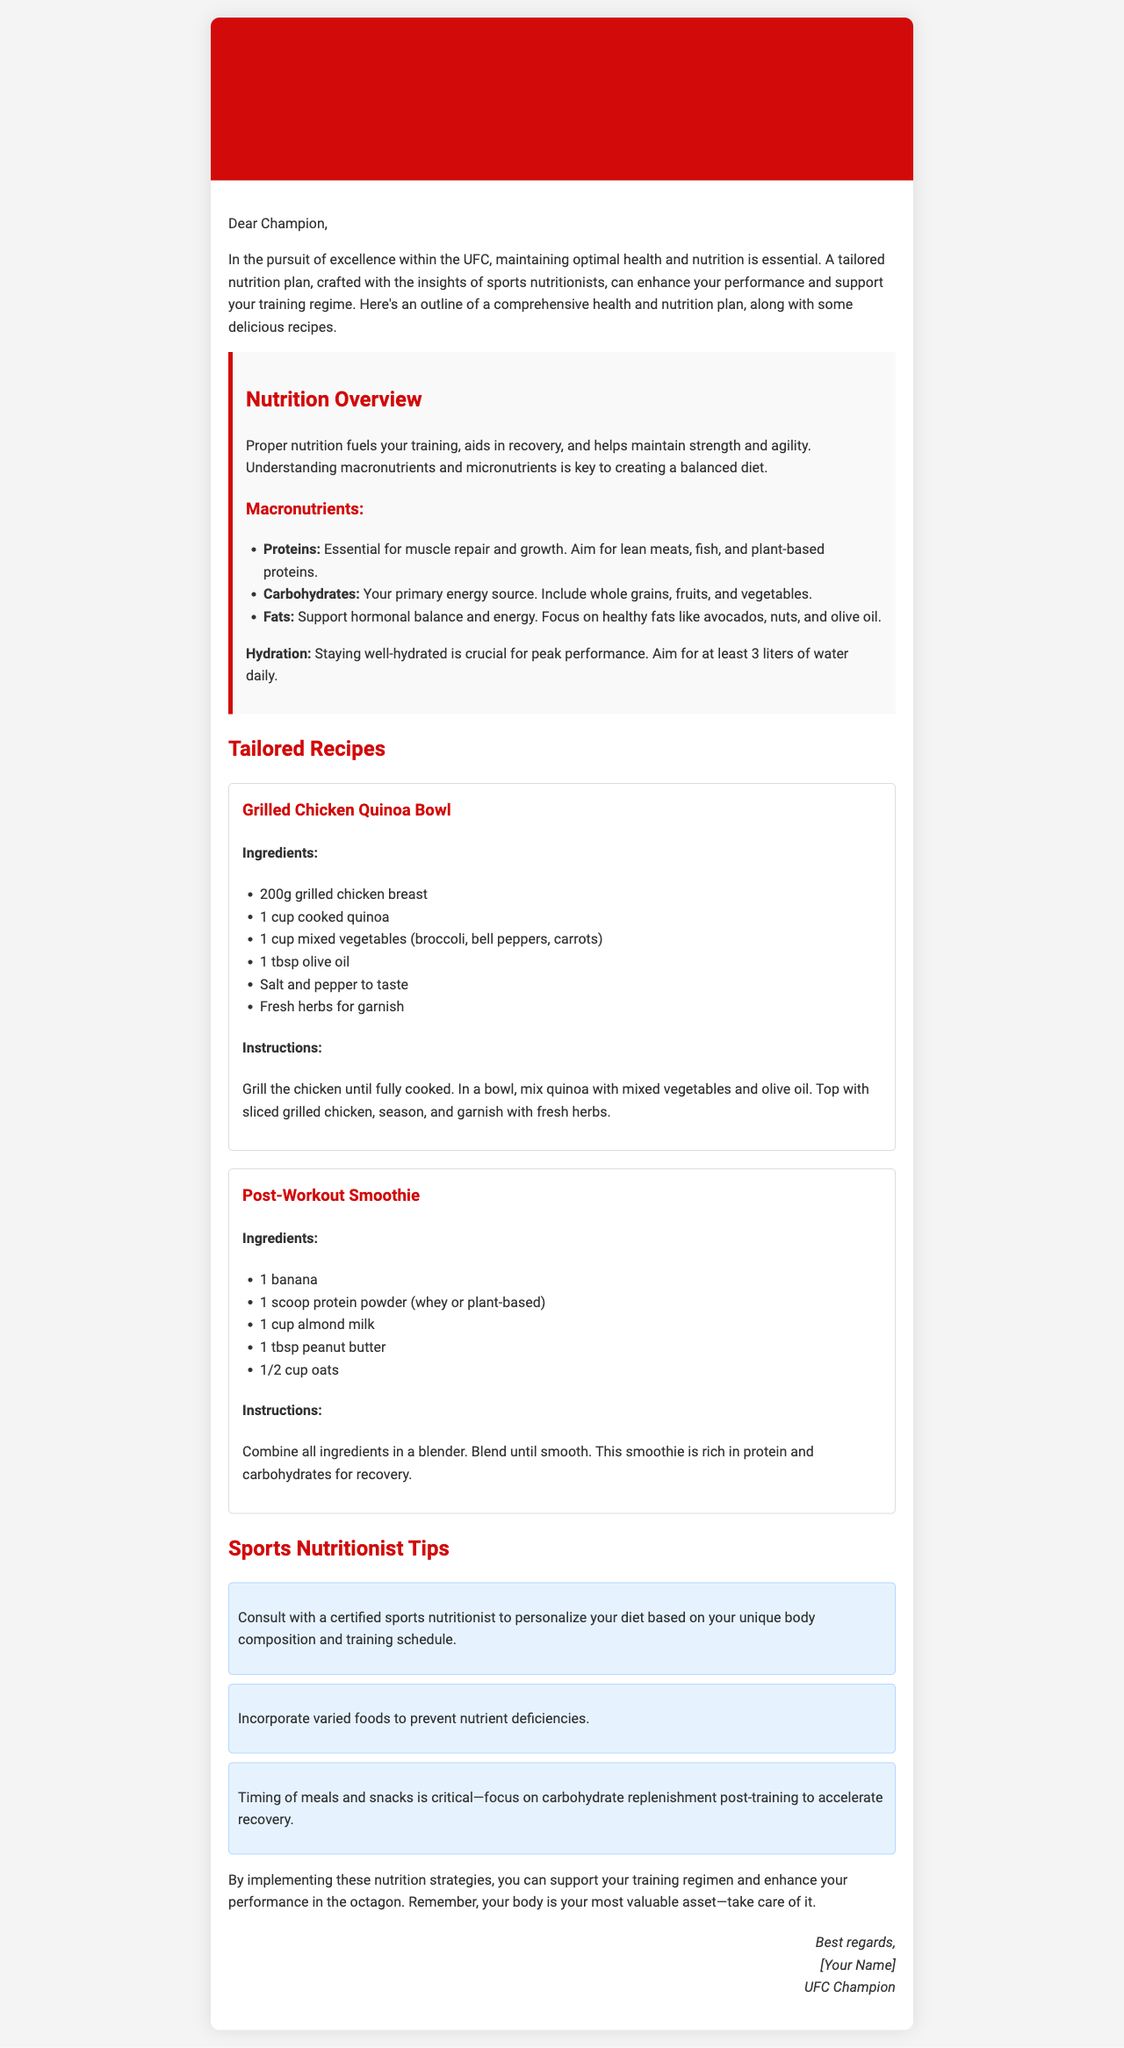What is the title of the email? The title of the email is specified in the `<title>` tag, which states "UFC Champion's Health and Nutrition Plan".
Answer: UFC Champion's Health and Nutrition Plan How many liters of water should be consumed daily? The document states that one should aim for at least 3 liters of water daily for hydration.
Answer: 3 liters What is a key component of the Grilled Chicken Quinoa Bowl recipe? The key component is the grilled chicken breast, which is listed as an ingredient in the recipe.
Answer: Grilled chicken breast What type of fat is recommended in the nutrition overview? The document suggests focusing on healthy fats like avocados, nuts, and olive oil.
Answer: Healthy fats What is the primary energy source mentioned? The primary energy source mentioned in the nutrition overview is carbohydrates, which include whole grains, fruits, and vegetables.
Answer: Carbohydrates Which ingredient is used for recovery in the Post-Workout Smoothie? The Post-Workout Smoothie includes protein powder as a key ingredient for recovery.
Answer: Protein powder What should you consult with a certified sports nutritionist about? You should consult with a certified sports nutritionist to personalize your diet based on your unique body composition and training schedule.
Answer: Diet personalization What is one of the tips provided for meal timing? The document states that timing of meals and snacks is critical, focusing on carbohydrate replenishment post-training to accelerate recovery.
Answer: Carbohydrate replenishment post-training 